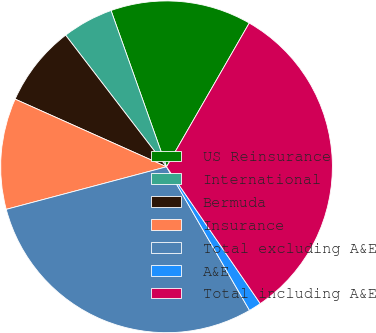Convert chart. <chart><loc_0><loc_0><loc_500><loc_500><pie_chart><fcel>US Reinsurance<fcel>International<fcel>Bermuda<fcel>Insurance<fcel>Total excluding A&E<fcel>A&E<fcel>Total including A&E<nl><fcel>13.74%<fcel>4.98%<fcel>7.9%<fcel>10.82%<fcel>29.21%<fcel>1.22%<fcel>32.13%<nl></chart> 